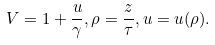<formula> <loc_0><loc_0><loc_500><loc_500>V = 1 + \frac { u } { \gamma } , \rho = \frac { z } { \tau } , u = u ( \rho ) .</formula> 